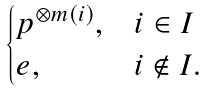Convert formula to latex. <formula><loc_0><loc_0><loc_500><loc_500>\begin{cases} p ^ { \otimes m ( i ) } , & i \in I \\ e , & i \notin I . \end{cases}</formula> 